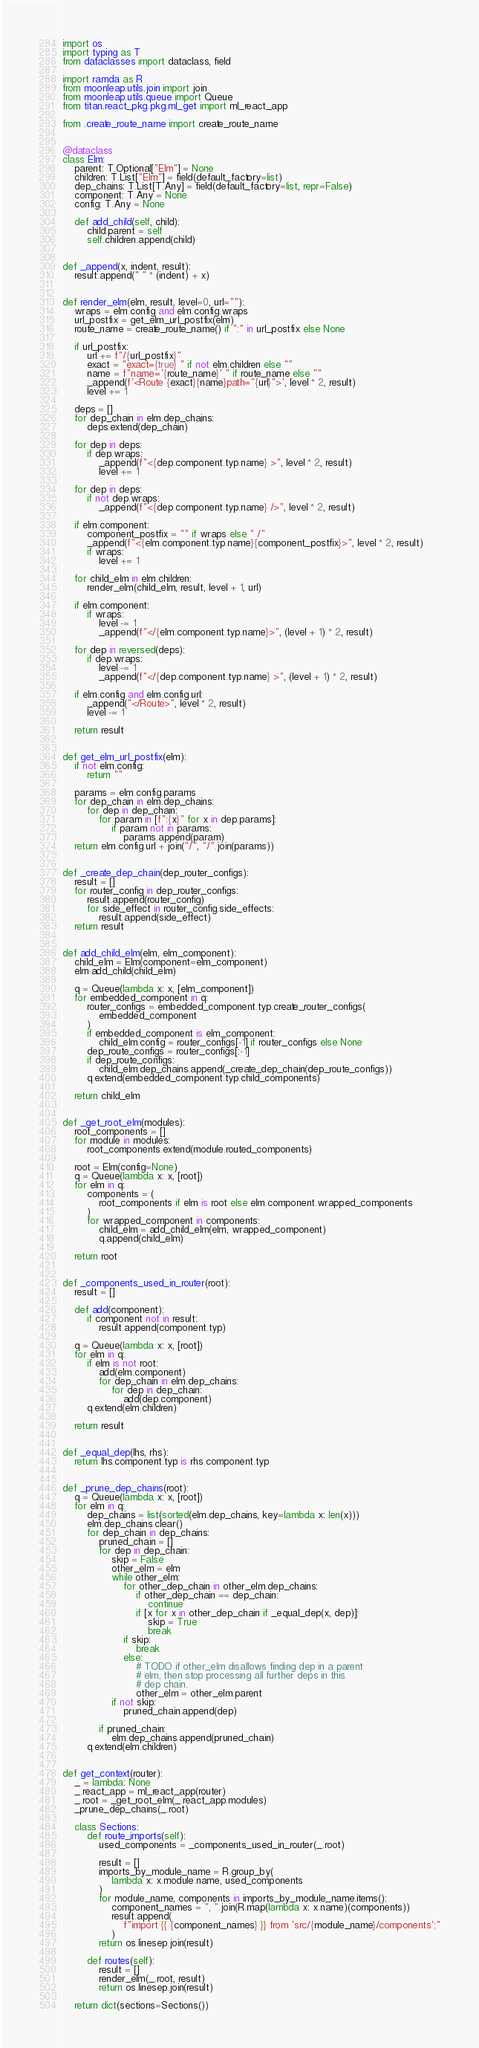Convert code to text. <code><loc_0><loc_0><loc_500><loc_500><_Python_>import os
import typing as T
from dataclasses import dataclass, field

import ramda as R
from moonleap.utils.join import join
from moonleap.utils.queue import Queue
from titan.react_pkg.pkg.ml_get import ml_react_app

from .create_route_name import create_route_name


@dataclass
class Elm:
    parent: T.Optional["Elm"] = None
    children: T.List["Elm"] = field(default_factory=list)
    dep_chains: T.List[T.Any] = field(default_factory=list, repr=False)
    component: T.Any = None
    config: T.Any = None

    def add_child(self, child):
        child.parent = self
        self.children.append(child)


def _append(x, indent, result):
    result.append(" " * (indent) + x)


def render_elm(elm, result, level=0, url=""):
    wraps = elm.config and elm.config.wraps
    url_postfix = get_elm_url_postfix(elm)
    route_name = create_route_name() if ":" in url_postfix else None

    if url_postfix:
        url += f"/{url_postfix}"
        exact = "exact={true} " if not elm.children else ""
        name = f"name='{route_name}' " if route_name else ""
        _append(f'<Route {exact}{name}path="{url}">', level * 2, result)
        level += 1

    deps = []
    for dep_chain in elm.dep_chains:
        deps.extend(dep_chain)

    for dep in deps:
        if dep.wraps:
            _append(f"<{dep.component.typ.name} >", level * 2, result)
            level += 1

    for dep in deps:
        if not dep.wraps:
            _append(f"<{dep.component.typ.name} />", level * 2, result)

    if elm.component:
        component_postfix = "" if wraps else " /"
        _append(f"<{elm.component.typ.name}{component_postfix}>", level * 2, result)
        if wraps:
            level += 1

    for child_elm in elm.children:
        render_elm(child_elm, result, level + 1, url)

    if elm.component:
        if wraps:
            level -= 1
            _append(f"</{elm.component.typ.name}>", (level + 1) * 2, result)

    for dep in reversed(deps):
        if dep.wraps:
            level -= 1
            _append(f"</{dep.component.typ.name} >", (level + 1) * 2, result)

    if elm.config and elm.config.url:
        _append("</Route>", level * 2, result)
        level -= 1

    return result


def get_elm_url_postfix(elm):
    if not elm.config:
        return ""

    params = elm.config.params
    for dep_chain in elm.dep_chains:
        for dep in dep_chain:
            for param in [f":{x}" for x in dep.params]:
                if param not in params:
                    params.append(param)
    return elm.config.url + join("/", "/".join(params))


def _create_dep_chain(dep_router_configs):
    result = []
    for router_config in dep_router_configs:
        result.append(router_config)
        for side_effect in router_config.side_effects:
            result.append(side_effect)
    return result


def add_child_elm(elm, elm_component):
    child_elm = Elm(component=elm_component)
    elm.add_child(child_elm)

    q = Queue(lambda x: x, [elm_component])
    for embedded_component in q:
        router_configs = embedded_component.typ.create_router_configs(
            embedded_component
        )
        if embedded_component is elm_component:
            child_elm.config = router_configs[-1] if router_configs else None
        dep_route_configs = router_configs[:-1]
        if dep_route_configs:
            child_elm.dep_chains.append(_create_dep_chain(dep_route_configs))
        q.extend(embedded_component.typ.child_components)

    return child_elm


def _get_root_elm(modules):
    root_components = []
    for module in modules:
        root_components.extend(module.routed_components)

    root = Elm(config=None)
    q = Queue(lambda x: x, [root])
    for elm in q:
        components = (
            root_components if elm is root else elm.component.wrapped_components
        )
        for wrapped_component in components:
            child_elm = add_child_elm(elm, wrapped_component)
            q.append(child_elm)

    return root


def _components_used_in_router(root):
    result = []

    def add(component):
        if component not in result:
            result.append(component.typ)

    q = Queue(lambda x: x, [root])
    for elm in q:
        if elm is not root:
            add(elm.component)
            for dep_chain in elm.dep_chains:
                for dep in dep_chain:
                    add(dep.component)
        q.extend(elm.children)

    return result


def _equal_dep(lhs, rhs):
    return lhs.component.typ is rhs.component.typ


def _prune_dep_chains(root):
    q = Queue(lambda x: x, [root])
    for elm in q:
        dep_chains = list(sorted(elm.dep_chains, key=lambda x: len(x)))
        elm.dep_chains.clear()
        for dep_chain in dep_chains:
            pruned_chain = []
            for dep in dep_chain:
                skip = False
                other_elm = elm
                while other_elm:
                    for other_dep_chain in other_elm.dep_chains:
                        if other_dep_chain == dep_chain:
                            continue
                        if [x for x in other_dep_chain if _equal_dep(x, dep)]:
                            skip = True
                            break
                    if skip:
                        break
                    else:
                        # TODO if other_elm disallows finding dep in a parent
                        # elm, then stop processing all further deps in this
                        # dep chain.
                        other_elm = other_elm.parent
                if not skip:
                    pruned_chain.append(dep)

            if pruned_chain:
                elm.dep_chains.append(pruned_chain)
        q.extend(elm.children)


def get_context(router):
    _ = lambda: None
    _.react_app = ml_react_app(router)
    _.root = _get_root_elm(_.react_app.modules)
    _prune_dep_chains(_.root)

    class Sections:
        def route_imports(self):
            used_components = _components_used_in_router(_.root)

            result = []
            imports_by_module_name = R.group_by(
                lambda x: x.module.name, used_components
            )
            for module_name, components in imports_by_module_name.items():
                component_names = ", ".join(R.map(lambda x: x.name)(components))
                result.append(
                    f"import {{ {component_names} }} from 'src/{module_name}/components';"
                )
            return os.linesep.join(result)

        def routes(self):
            result = []
            render_elm(_.root, result)
            return os.linesep.join(result)

    return dict(sections=Sections())
</code> 